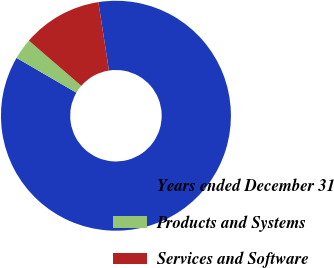<chart> <loc_0><loc_0><loc_500><loc_500><pie_chart><fcel>Years ended December 31<fcel>Products and Systems<fcel>Services and Software<nl><fcel>85.84%<fcel>2.94%<fcel>11.23%<nl></chart> 